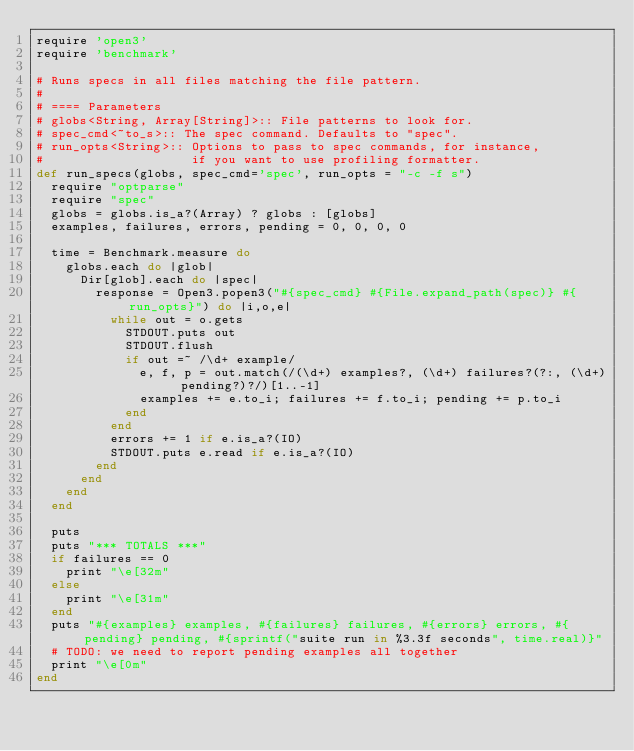<code> <loc_0><loc_0><loc_500><loc_500><_Ruby_>require 'open3'
require 'benchmark'

# Runs specs in all files matching the file pattern.
#
# ==== Parameters
# globs<String, Array[String]>:: File patterns to look for.
# spec_cmd<~to_s>:: The spec command. Defaults to "spec".
# run_opts<String>:: Options to pass to spec commands, for instance,
#                    if you want to use profiling formatter.
def run_specs(globs, spec_cmd='spec', run_opts = "-c -f s")
  require "optparse"
  require "spec"
  globs = globs.is_a?(Array) ? globs : [globs]
  examples, failures, errors, pending = 0, 0, 0, 0

  time = Benchmark.measure do
    globs.each do |glob|
      Dir[glob].each do |spec|
        response = Open3.popen3("#{spec_cmd} #{File.expand_path(spec)} #{run_opts}") do |i,o,e|
          while out = o.gets
            STDOUT.puts out
            STDOUT.flush
            if out =~ /\d+ example/
              e, f, p = out.match(/(\d+) examples?, (\d+) failures?(?:, (\d+) pending?)?/)[1..-1]
              examples += e.to_i; failures += f.to_i; pending += p.to_i
            end
          end
          errors += 1 if e.is_a?(IO)
          STDOUT.puts e.read if e.is_a?(IO)
        end
      end
    end
  end

  puts
  puts "*** TOTALS ***"
  if failures == 0
    print "\e[32m"
  else
    print "\e[31m"
  end
  puts "#{examples} examples, #{failures} failures, #{errors} errors, #{pending} pending, #{sprintf("suite run in %3.3f seconds", time.real)}"
  # TODO: we need to report pending examples all together
  print "\e[0m"
end
</code> 